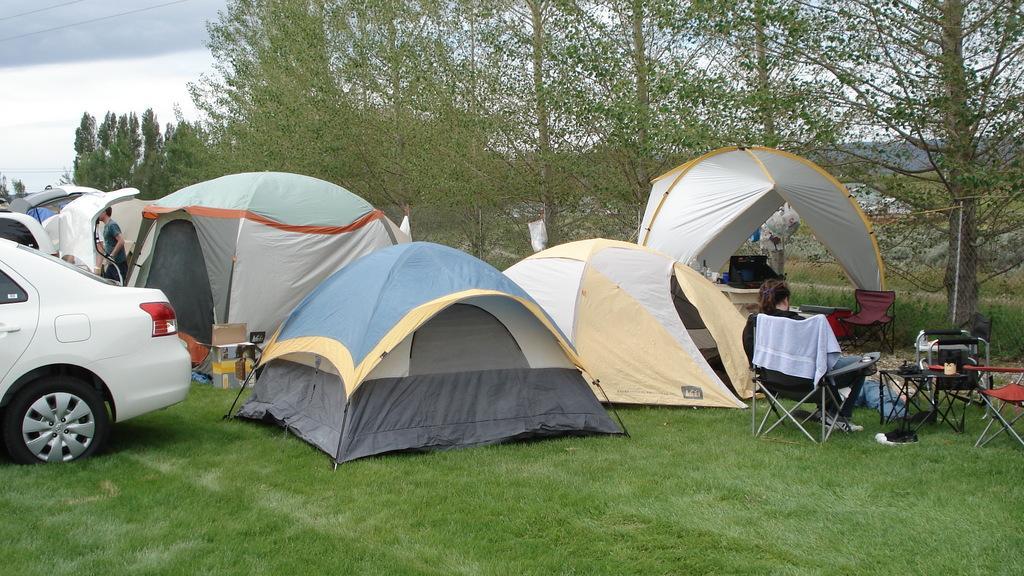Please provide a concise description of this image. In this image we can see tents, vehicle, persons, chairs, table, trees, sky and clouds. 